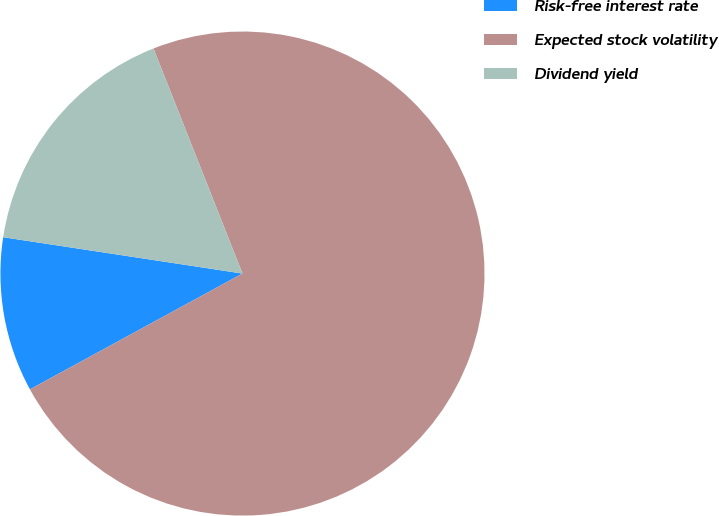Convert chart. <chart><loc_0><loc_0><loc_500><loc_500><pie_chart><fcel>Risk-free interest rate<fcel>Expected stock volatility<fcel>Dividend yield<nl><fcel>10.34%<fcel>73.06%<fcel>16.61%<nl></chart> 